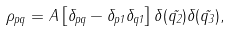<formula> <loc_0><loc_0><loc_500><loc_500>\rho _ { p q } = A \left [ \delta _ { p q } - \delta _ { p 1 } \delta _ { q 1 } \right ] \delta ( \vec { q _ { 2 } } ) \delta ( \vec { q _ { 3 } } ) ,</formula> 